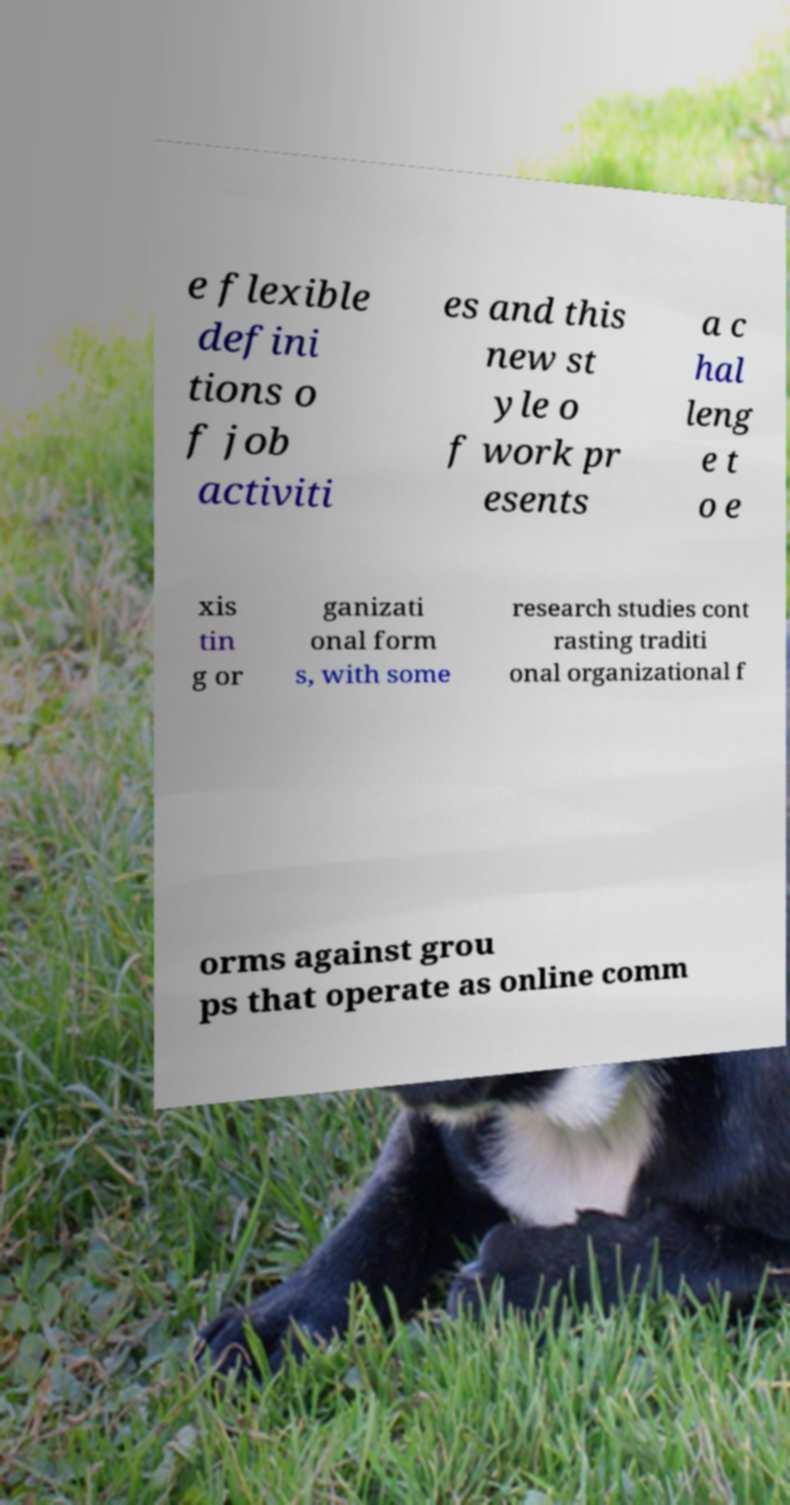Could you assist in decoding the text presented in this image and type it out clearly? e flexible defini tions o f job activiti es and this new st yle o f work pr esents a c hal leng e t o e xis tin g or ganizati onal form s, with some research studies cont rasting traditi onal organizational f orms against grou ps that operate as online comm 